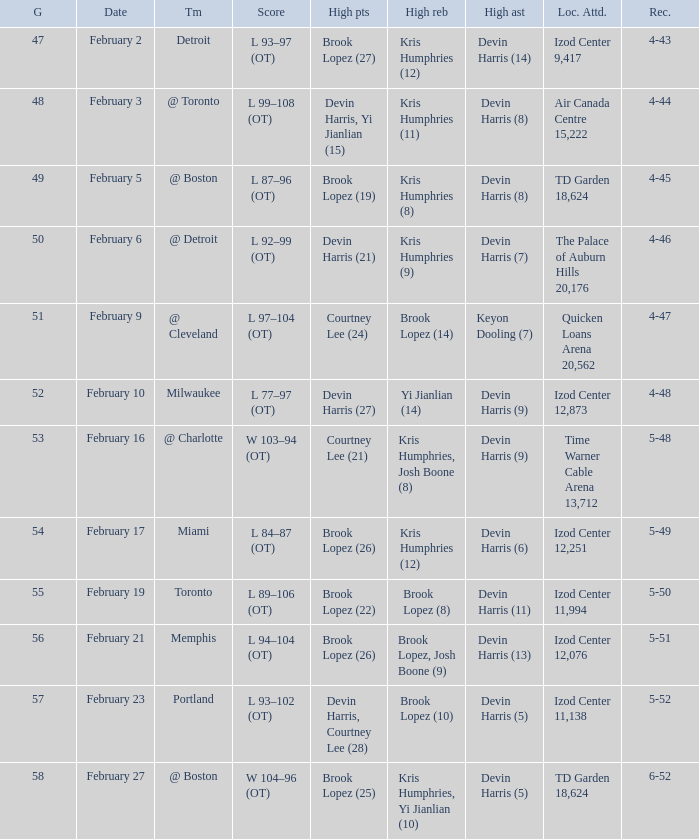What's the highest game number for a game in which Kris Humphries (8) did the high rebounds? 49.0. 